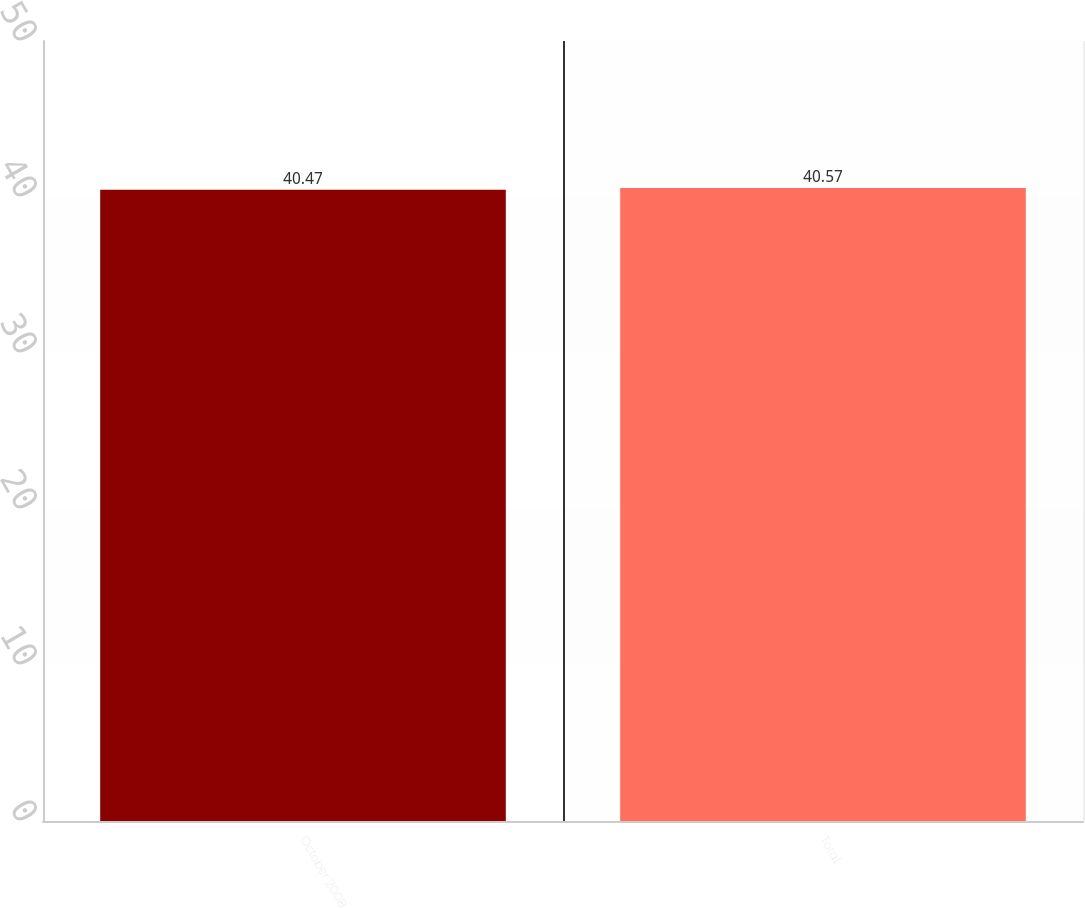Convert chart to OTSL. <chart><loc_0><loc_0><loc_500><loc_500><bar_chart><fcel>October 2008<fcel>Total<nl><fcel>40.47<fcel>40.57<nl></chart> 